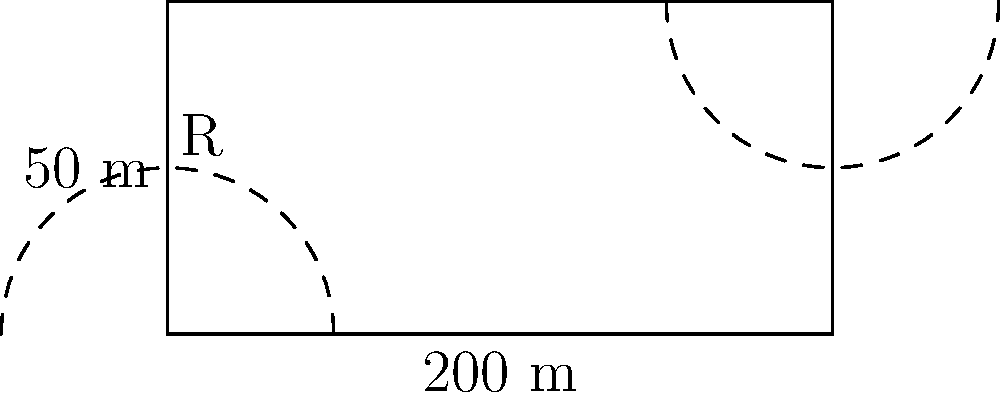As a former Bulldogs player, you're reminiscing about Drake Stadium. The track is shaped like an oval with straight sides and semicircular ends. If the straight sides are 200 meters long and the width of the track is 50 meters, what is the total circumference of the track? Let's approach this step-by-step:

1) The track is composed of two straight sections and two semicircular ends.

2) We're given that:
   - The straight sides are 200 meters long
   - The width of the track is 50 meters

3) The radius of each semicircle is half the width of the track:
   $R = 50 \div 2 = 25$ meters

4) The length of the straight sections:
   $L_{straight} = 200 \times 2 = 400$ meters

5) The circumference of a full circle with radius 25 meters would be:
   $C_{full} = 2\pi R = 2\pi(25) = 50\pi$ meters

6) But we only need two semicircles, which is equivalent to one full circle:
   $L_{curved} = 50\pi$ meters

7) The total circumference is the sum of the straight sections and the curved sections:
   $C_{total} = L_{straight} + L_{curved} = 400 + 50\pi$ meters

8) Calculating this (with $\pi \approx 3.14159$):
   $C_{total} \approx 400 + 50(3.14159) \approx 400 + 157.08 \approx 557.08$ meters
Answer: $400 + 50\pi \approx 557.08$ meters 